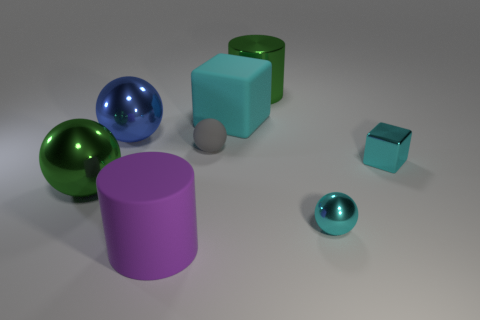What is the tiny cyan block made of?
Give a very brief answer. Metal. What is the color of the large object that is both behind the big purple matte cylinder and in front of the tiny gray matte thing?
Keep it short and to the point. Green. Is the number of small objects that are in front of the large purple cylinder the same as the number of big blue metallic spheres in front of the small cyan metallic cube?
Your answer should be compact. Yes. What is the color of the big cube that is made of the same material as the gray ball?
Your answer should be very brief. Cyan. Is the color of the large metallic cylinder the same as the metal sphere that is behind the tiny metal cube?
Keep it short and to the point. No. There is a green object to the right of the small thing on the left side of the metal cylinder; are there any large metallic things that are on the right side of it?
Keep it short and to the point. No. There is a gray thing that is the same material as the big cyan cube; what is its shape?
Offer a terse response. Sphere. Is there anything else that is the same shape as the big purple thing?
Make the answer very short. Yes. What is the shape of the tiny gray matte thing?
Make the answer very short. Sphere. There is a small thing that is left of the green shiny cylinder; does it have the same shape as the cyan rubber object?
Keep it short and to the point. No. 